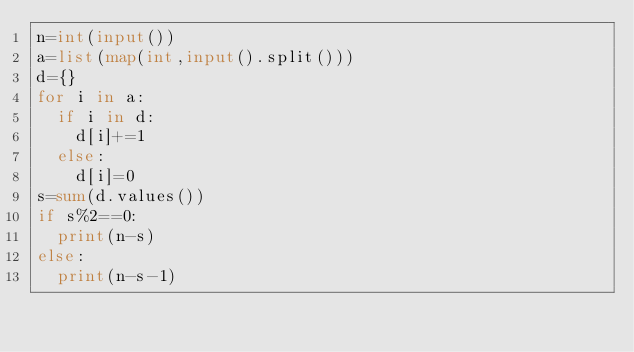<code> <loc_0><loc_0><loc_500><loc_500><_Python_>n=int(input())
a=list(map(int,input().split()))
d={}
for i in a:
  if i in d:
    d[i]+=1
  else:
    d[i]=0
s=sum(d.values())
if s%2==0:
  print(n-s)
else:
  print(n-s-1)</code> 